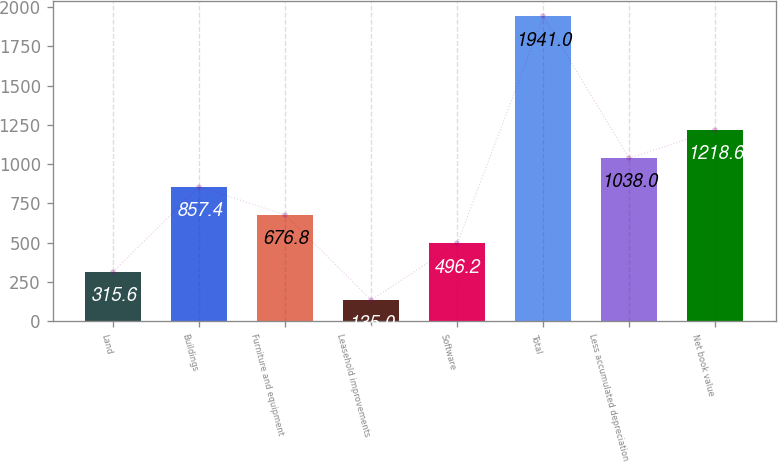Convert chart to OTSL. <chart><loc_0><loc_0><loc_500><loc_500><bar_chart><fcel>Land<fcel>Buildings<fcel>Furniture and equipment<fcel>Leasehold improvements<fcel>Software<fcel>Total<fcel>Less accumulated depreciation<fcel>Net book value<nl><fcel>315.6<fcel>857.4<fcel>676.8<fcel>135<fcel>496.2<fcel>1941<fcel>1038<fcel>1218.6<nl></chart> 